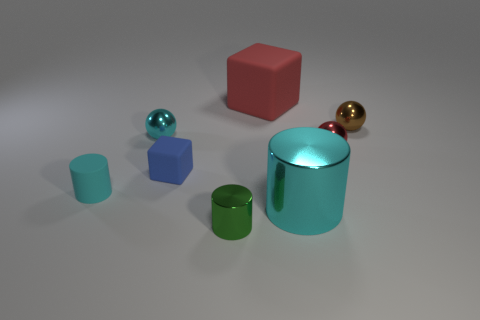Can you describe the shapes and colors of the objects in the image? Certainly! The image features a collection of geometric objects on a flat surface. From left to right, there's a small teal cylinder, a slightly larger blue cube, a small turquoise sphere, a red cube, a small brown sphere, a large cyan cylinder, and a small green cylinder beside a bronze sphere. 